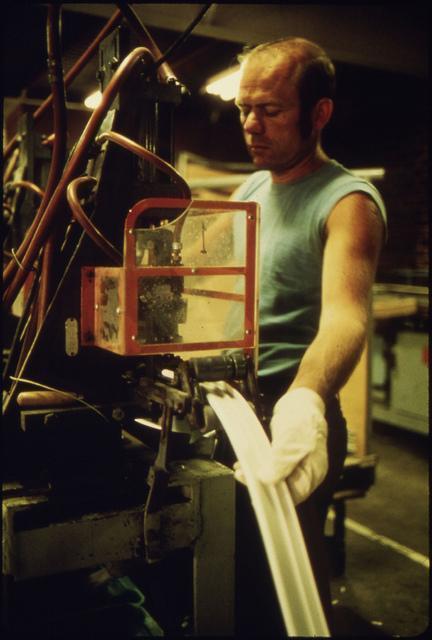How many sandwiches are on the plate?
Give a very brief answer. 0. 